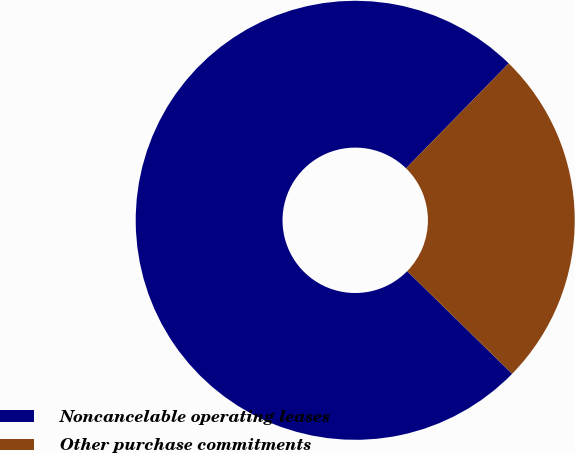Convert chart to OTSL. <chart><loc_0><loc_0><loc_500><loc_500><pie_chart><fcel>Noncancelable operating leases<fcel>Other purchase commitments<nl><fcel>75.0%<fcel>25.0%<nl></chart> 